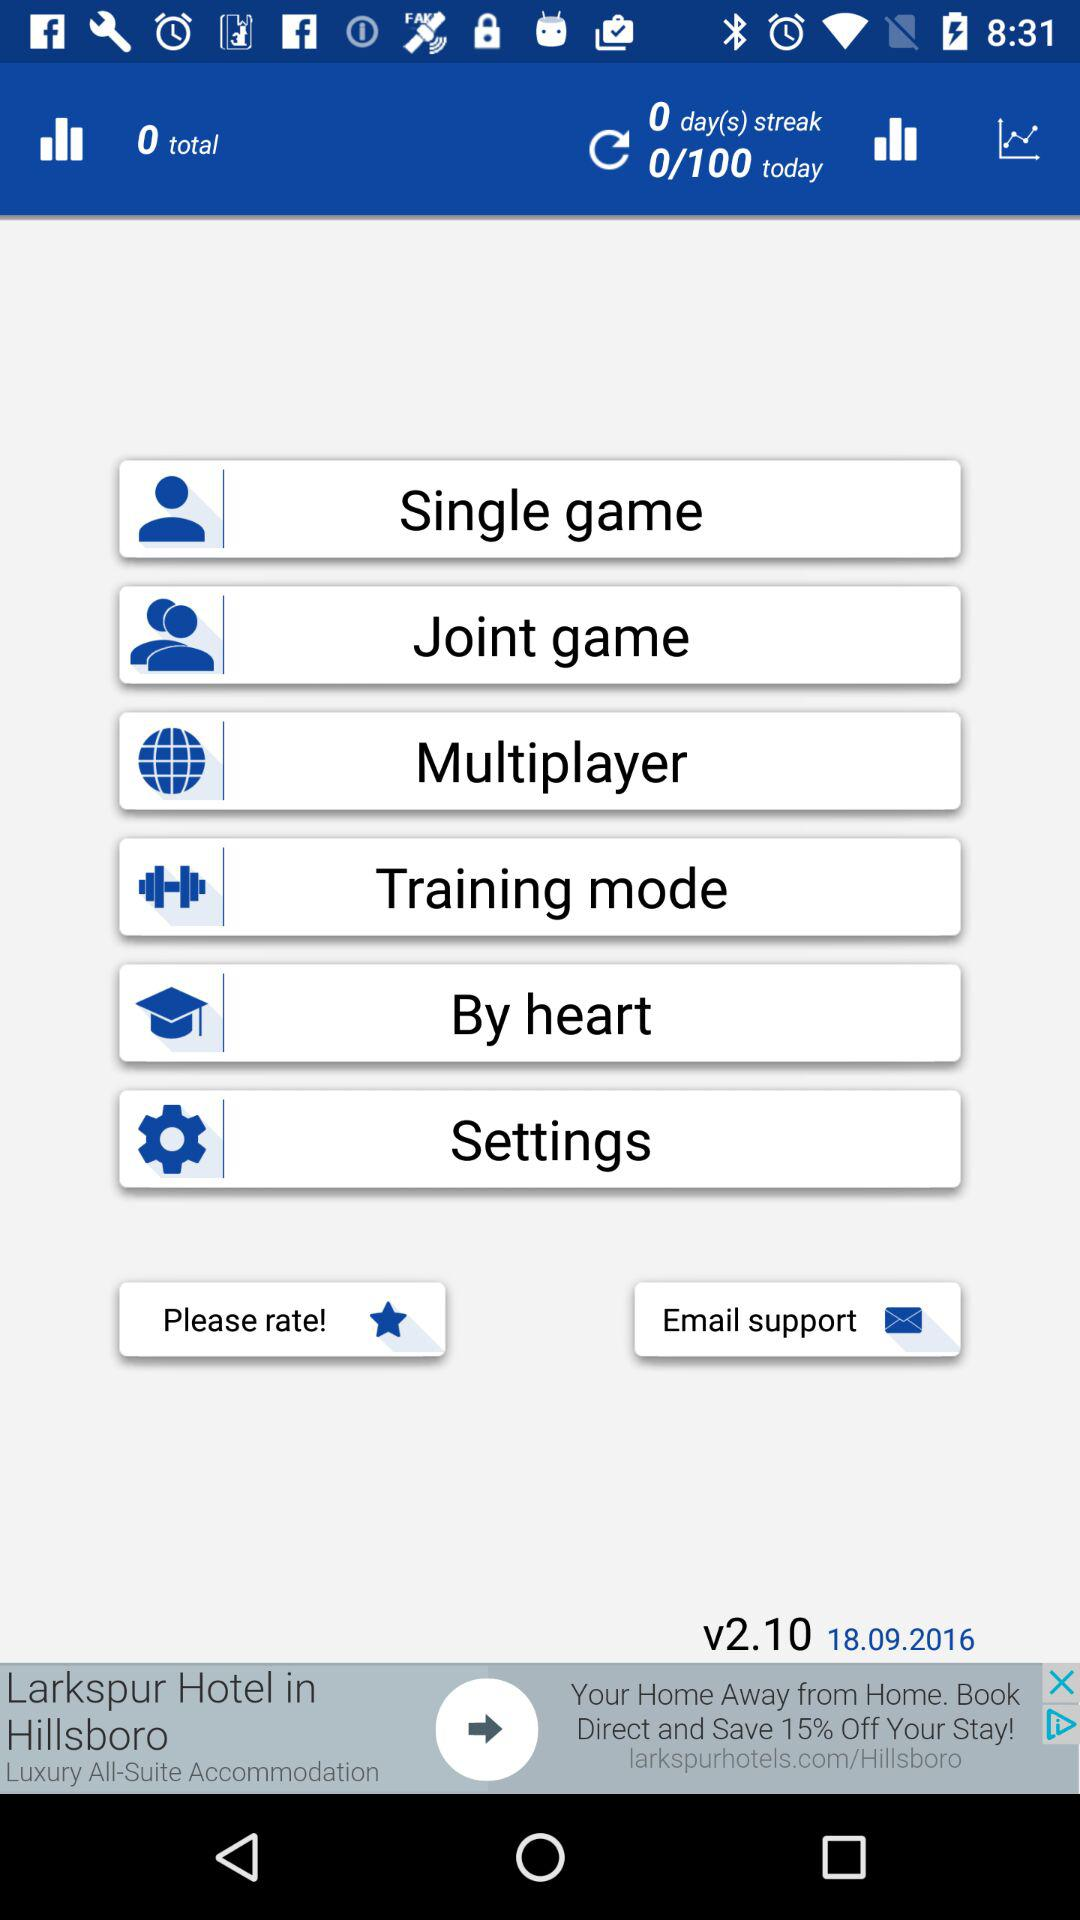What version is it? The version is v2.10. 